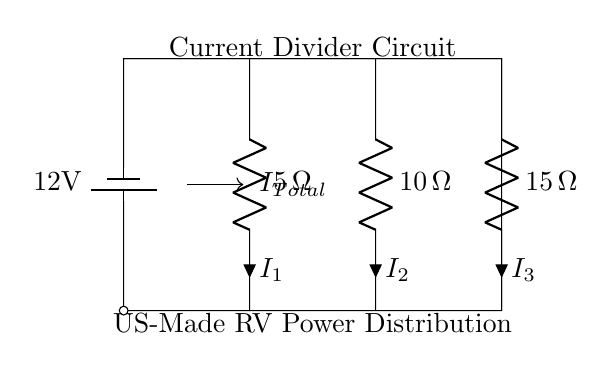What is the total voltage supplied to the circuit? The voltage supplied to the battery is indicated as 12V, which is the potential difference across the power supply in the circuit.
Answer: 12V What are the resistance values in this circuit? The circuit contains three resistors with values: 5 ohms, 10 ohms, and 15 ohms, as labeled next to each resistor in the diagram.
Answer: 5 ohm, 10 ohm, 15 ohm How many resistors are in the parallel circuit? There are three resistors connected in parallel in this circuit, which are all connected to the same voltage source.
Answer: 3 What is the total current entering the circuit? The total current is denoted as I_total, which is the current that flows into the parallel arrangement of resistors and splits according to their resistance values.
Answer: I_total Which resistor has the highest resistance? The resistor with the highest value is the one labeled as 15 ohms, indicating it will carry the least amount of current in the parallel configuration.
Answer: 15 ohm What is the relationship between the resistors in a current divider? In a current divider, the total current is divided among the resistors inversely proportional to their resistance values; the more resistance, the less current flows through that branch.
Answer: Inversely proportional What current flows through the 10-ohm resistor? The current flowing through each resistor can be calculated using the formula I = V/R; since there is a total of 12V across the 10-ohm resistor, the current can be found by dividing 12V by 10 ohms.
Answer: 1.2 A 